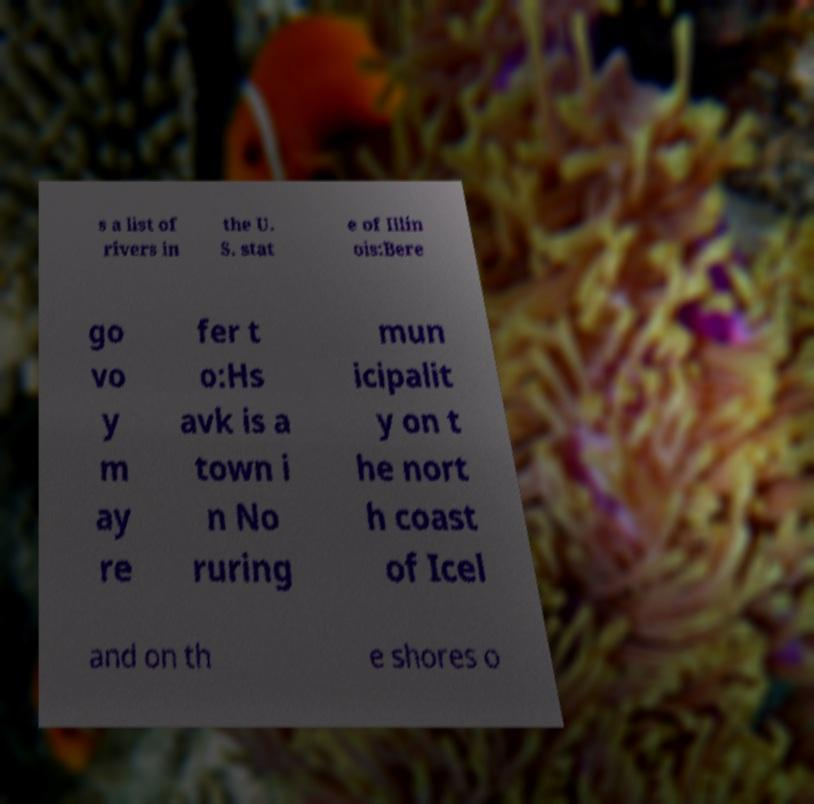Can you read and provide the text displayed in the image?This photo seems to have some interesting text. Can you extract and type it out for me? s a list of rivers in the U. S. stat e of Illin ois:Bere go vo y m ay re fer t o:Hs avk is a town i n No ruring mun icipalit y on t he nort h coast of Icel and on th e shores o 